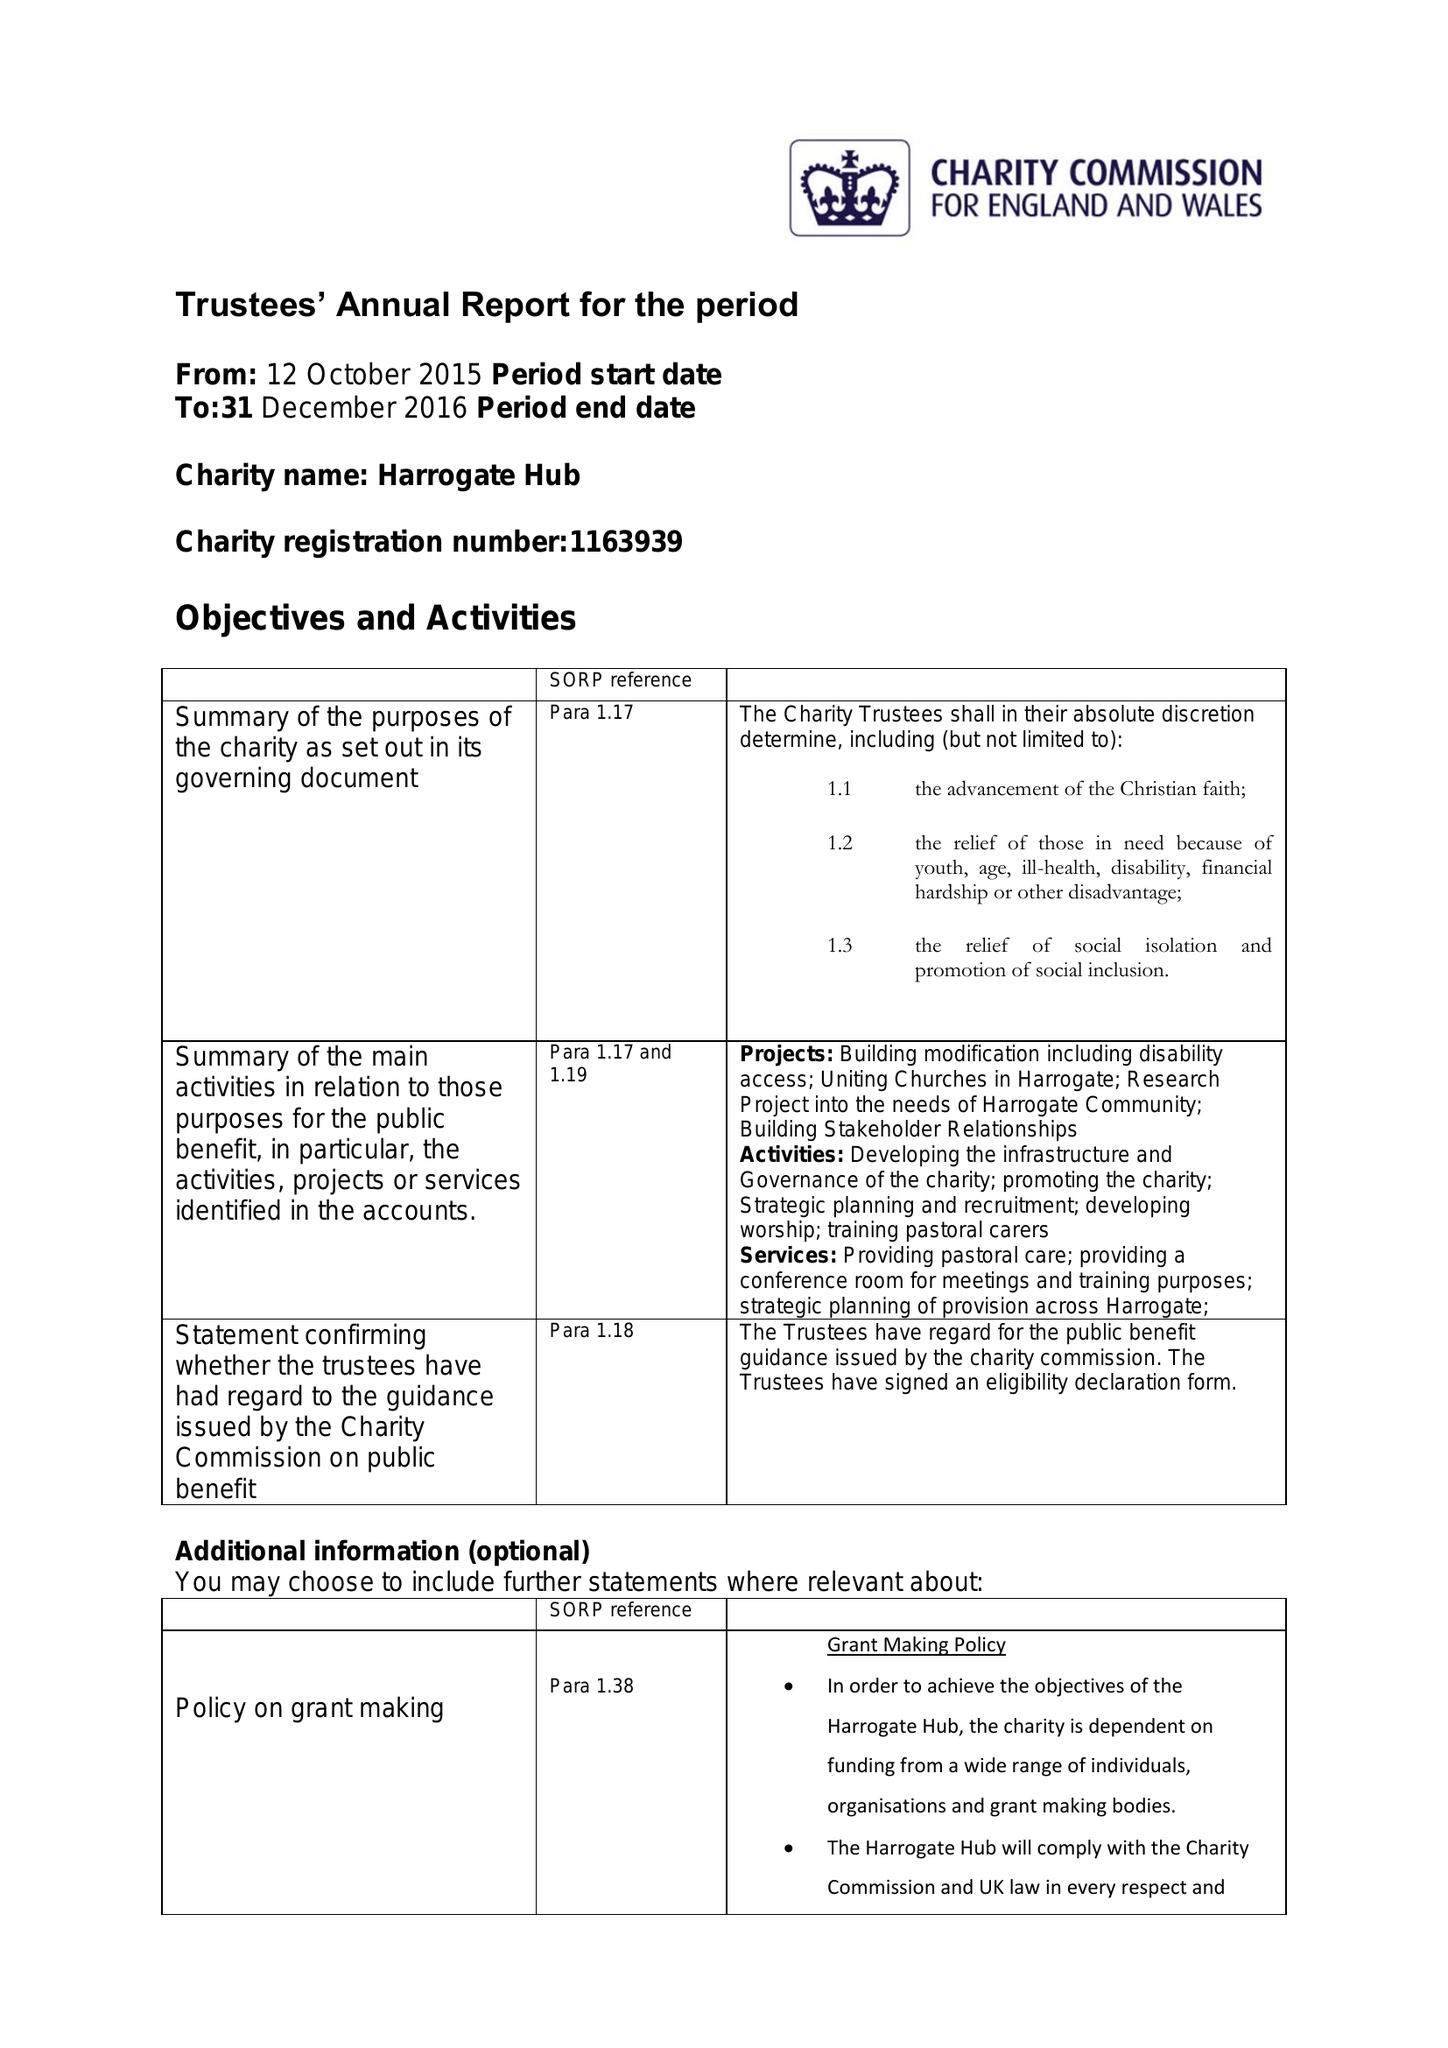What is the value for the charity_name?
Answer the question using a single word or phrase. Harrogate Hub 